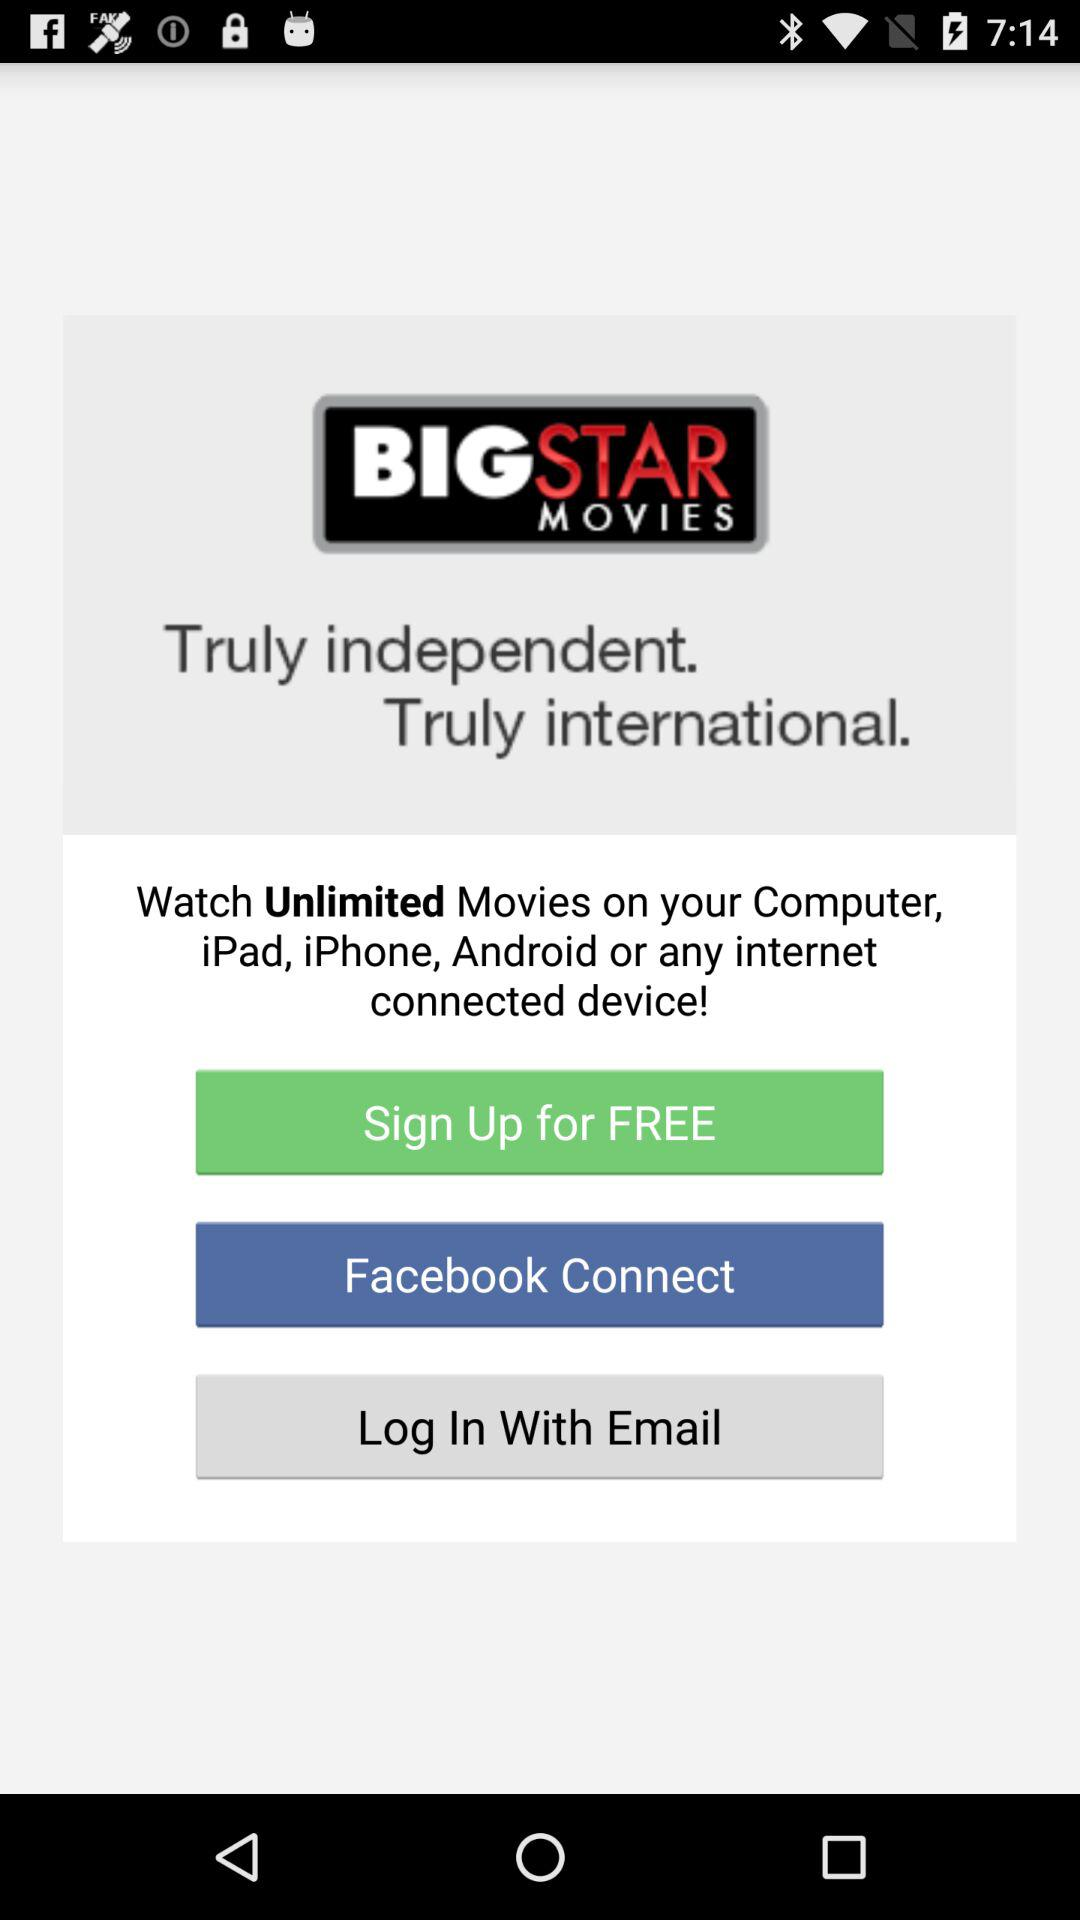How can we connect? You can connect with "Facebook" and "Email". 